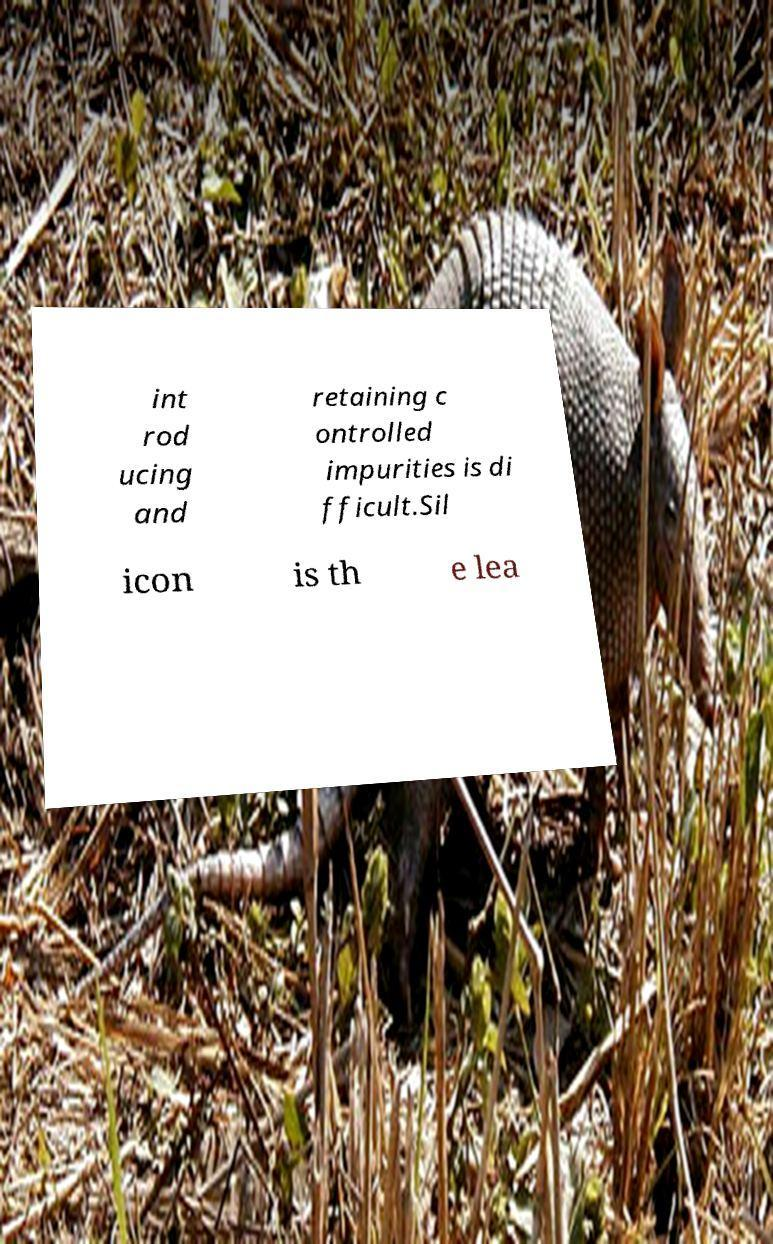Can you read and provide the text displayed in the image?This photo seems to have some interesting text. Can you extract and type it out for me? int rod ucing and retaining c ontrolled impurities is di fficult.Sil icon is th e lea 